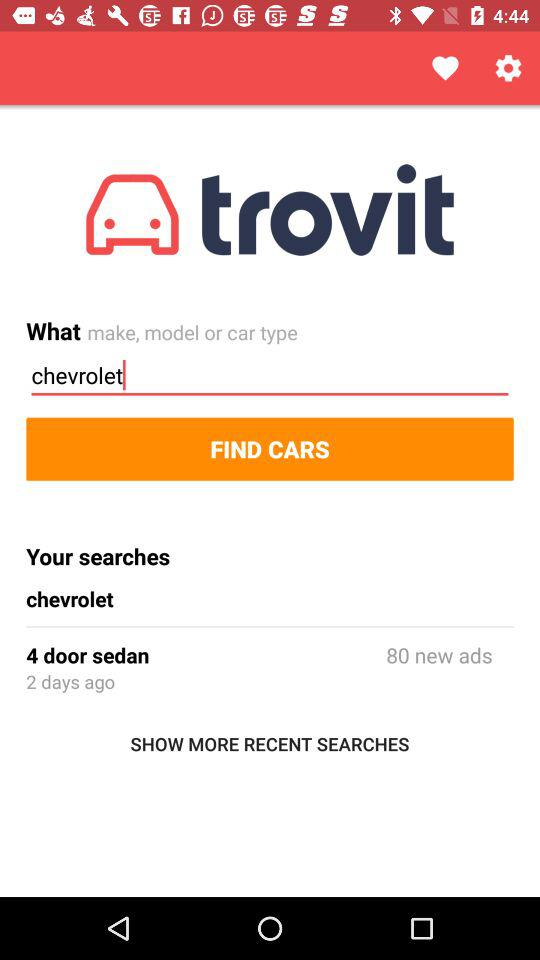What is the result for the "chevrolet" car search? The result for the "chevrolet" car search is 4 door sedan. 